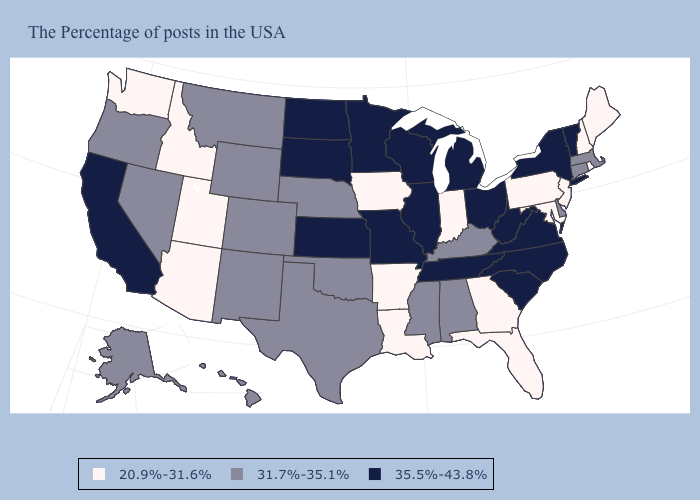Does Georgia have the lowest value in the USA?
Answer briefly. Yes. Among the states that border Oklahoma , does Missouri have the highest value?
Keep it brief. Yes. Which states have the lowest value in the Northeast?
Be succinct. Maine, Rhode Island, New Hampshire, New Jersey, Pennsylvania. Does Kansas have the lowest value in the MidWest?
Write a very short answer. No. Name the states that have a value in the range 35.5%-43.8%?
Be succinct. Vermont, New York, Virginia, North Carolina, South Carolina, West Virginia, Ohio, Michigan, Tennessee, Wisconsin, Illinois, Missouri, Minnesota, Kansas, South Dakota, North Dakota, California. Name the states that have a value in the range 20.9%-31.6%?
Concise answer only. Maine, Rhode Island, New Hampshire, New Jersey, Maryland, Pennsylvania, Florida, Georgia, Indiana, Louisiana, Arkansas, Iowa, Utah, Arizona, Idaho, Washington. How many symbols are there in the legend?
Concise answer only. 3. What is the value of New Mexico?
Keep it brief. 31.7%-35.1%. What is the value of Alaska?
Concise answer only. 31.7%-35.1%. What is the value of Nebraska?
Give a very brief answer. 31.7%-35.1%. Does Alabama have the lowest value in the USA?
Quick response, please. No. Name the states that have a value in the range 35.5%-43.8%?
Be succinct. Vermont, New York, Virginia, North Carolina, South Carolina, West Virginia, Ohio, Michigan, Tennessee, Wisconsin, Illinois, Missouri, Minnesota, Kansas, South Dakota, North Dakota, California. Name the states that have a value in the range 35.5%-43.8%?
Give a very brief answer. Vermont, New York, Virginia, North Carolina, South Carolina, West Virginia, Ohio, Michigan, Tennessee, Wisconsin, Illinois, Missouri, Minnesota, Kansas, South Dakota, North Dakota, California. Name the states that have a value in the range 31.7%-35.1%?
Answer briefly. Massachusetts, Connecticut, Delaware, Kentucky, Alabama, Mississippi, Nebraska, Oklahoma, Texas, Wyoming, Colorado, New Mexico, Montana, Nevada, Oregon, Alaska, Hawaii. What is the lowest value in the USA?
Write a very short answer. 20.9%-31.6%. 